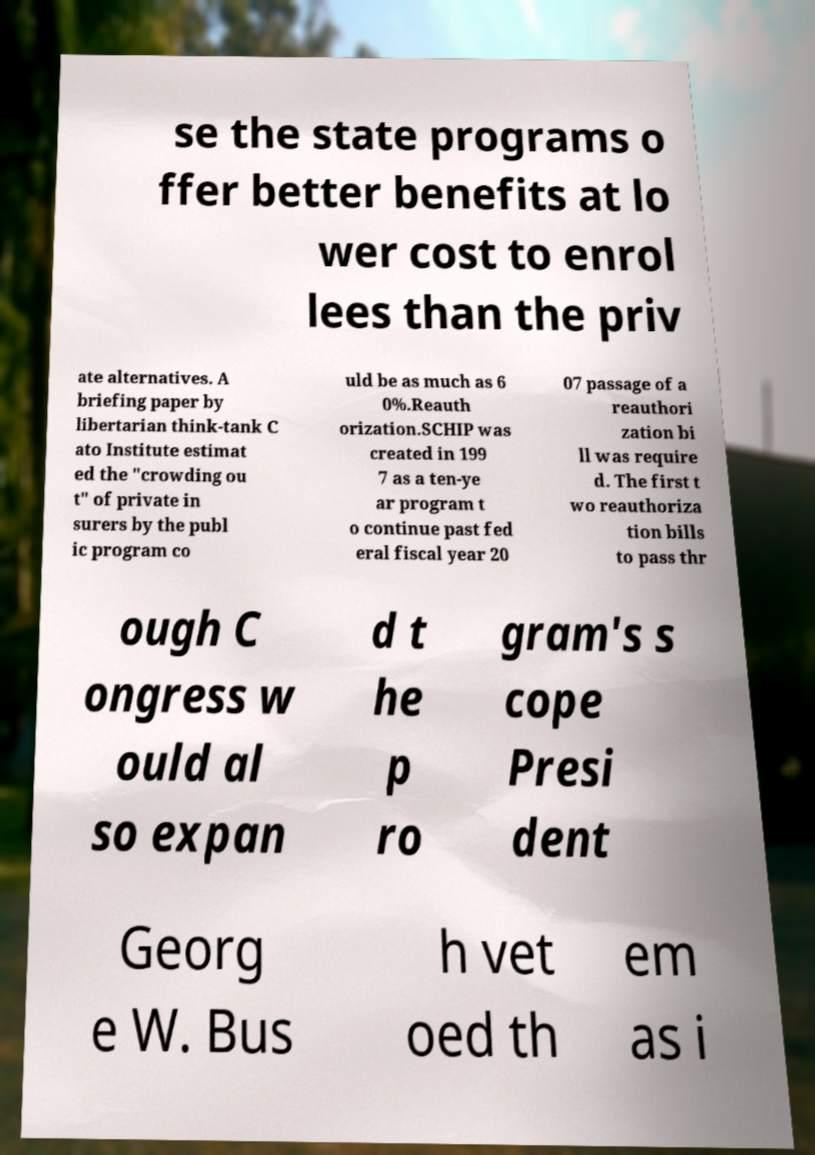Please identify and transcribe the text found in this image. se the state programs o ffer better benefits at lo wer cost to enrol lees than the priv ate alternatives. A briefing paper by libertarian think-tank C ato Institute estimat ed the "crowding ou t" of private in surers by the publ ic program co uld be as much as 6 0%.Reauth orization.SCHIP was created in 199 7 as a ten-ye ar program t o continue past fed eral fiscal year 20 07 passage of a reauthori zation bi ll was require d. The first t wo reauthoriza tion bills to pass thr ough C ongress w ould al so expan d t he p ro gram's s cope Presi dent Georg e W. Bus h vet oed th em as i 